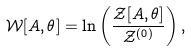<formula> <loc_0><loc_0><loc_500><loc_500>\mathcal { W } [ A , \theta ] = \ln \left ( \frac { \mathcal { Z } [ A , \theta ] } { { \mathcal { Z } } ^ { ( 0 ) } } \right ) ,</formula> 